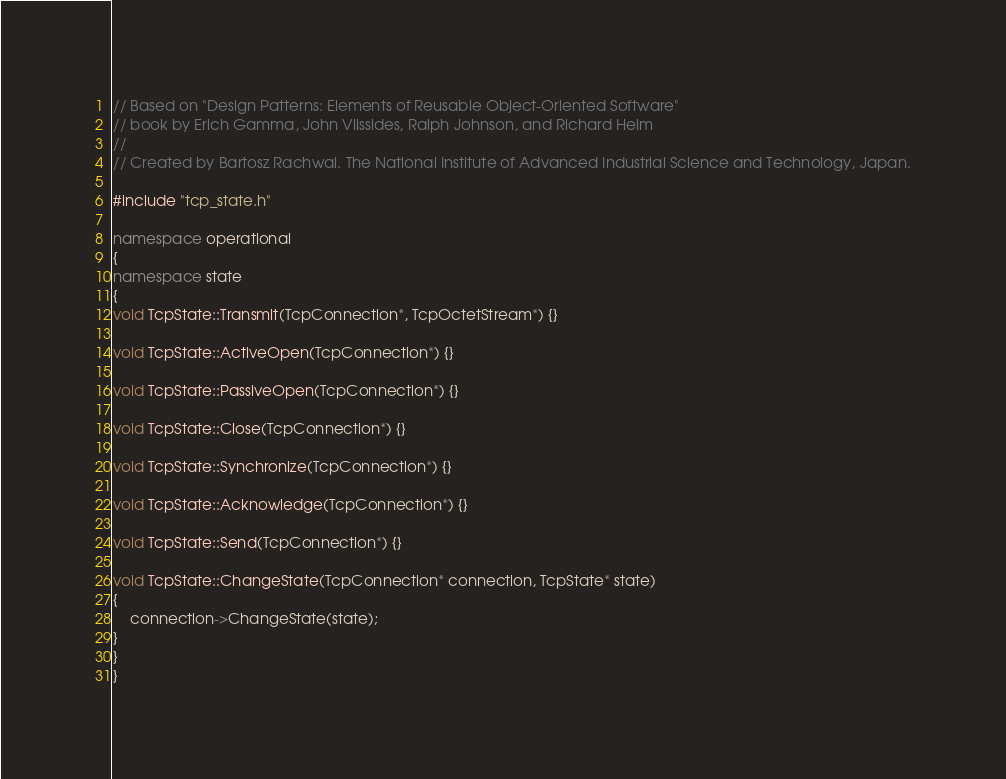<code> <loc_0><loc_0><loc_500><loc_500><_C++_>// Based on "Design Patterns: Elements of Reusable Object-Oriented Software"
// book by Erich Gamma, John Vlissides, Ralph Johnson, and Richard Helm 
//
// Created by Bartosz Rachwal. The National Institute of Advanced Industrial Science and Technology, Japan.

#include "tcp_state.h"

namespace operational
{
namespace state
{
void TcpState::Transmit(TcpConnection*, TcpOctetStream*) {}

void TcpState::ActiveOpen(TcpConnection*) {}

void TcpState::PassiveOpen(TcpConnection*) {}

void TcpState::Close(TcpConnection*) {}

void TcpState::Synchronize(TcpConnection*) {}

void TcpState::Acknowledge(TcpConnection*) {}

void TcpState::Send(TcpConnection*) {}

void TcpState::ChangeState(TcpConnection* connection, TcpState* state)
{
	connection->ChangeState(state);
}
}
}

</code> 